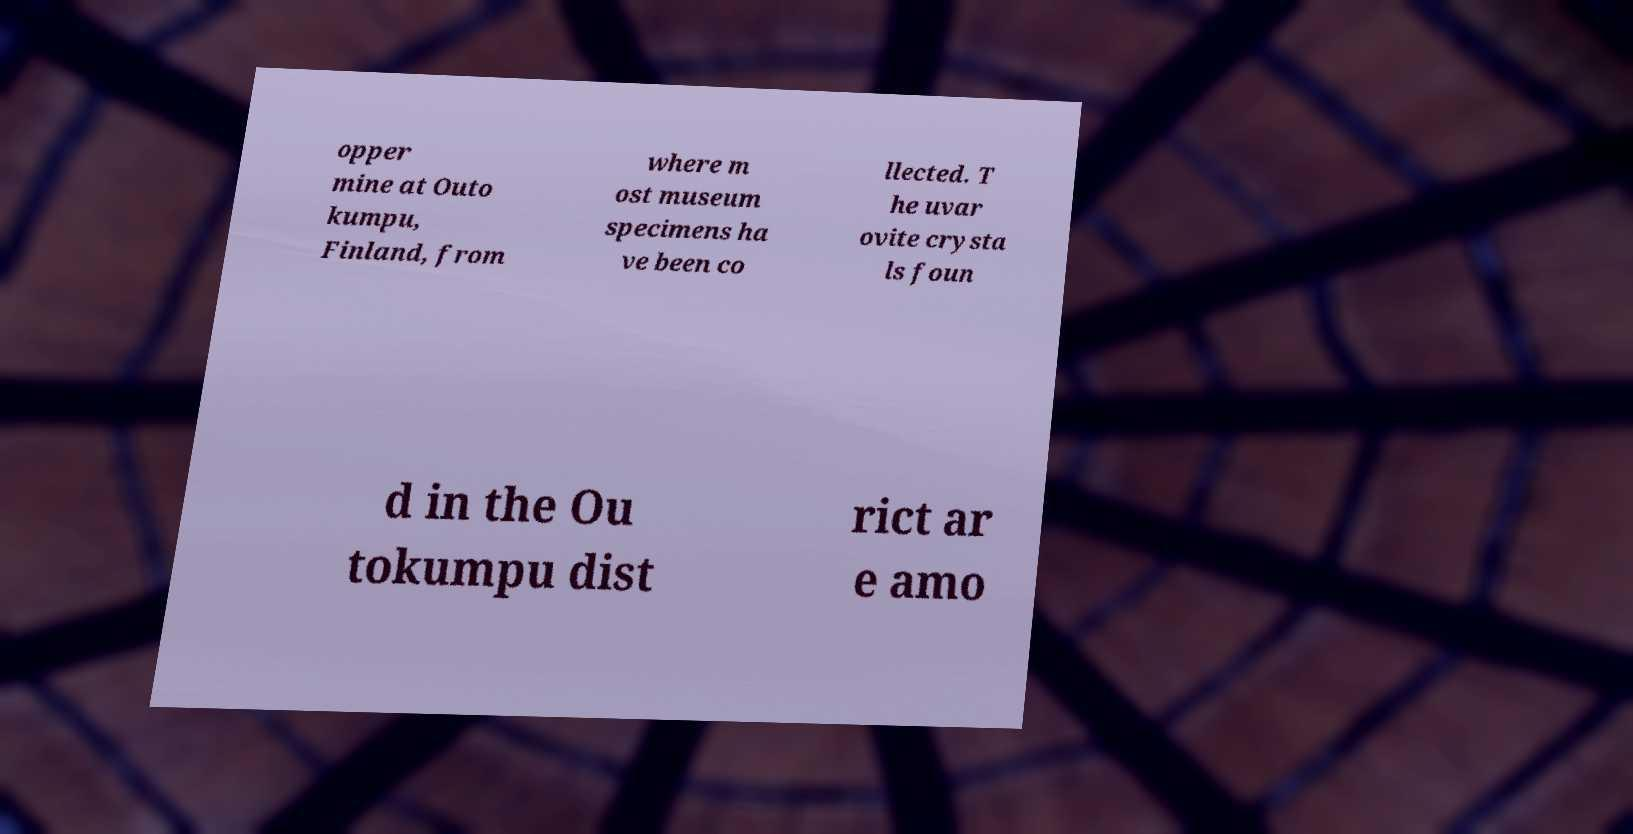There's text embedded in this image that I need extracted. Can you transcribe it verbatim? opper mine at Outo kumpu, Finland, from where m ost museum specimens ha ve been co llected. T he uvar ovite crysta ls foun d in the Ou tokumpu dist rict ar e amo 